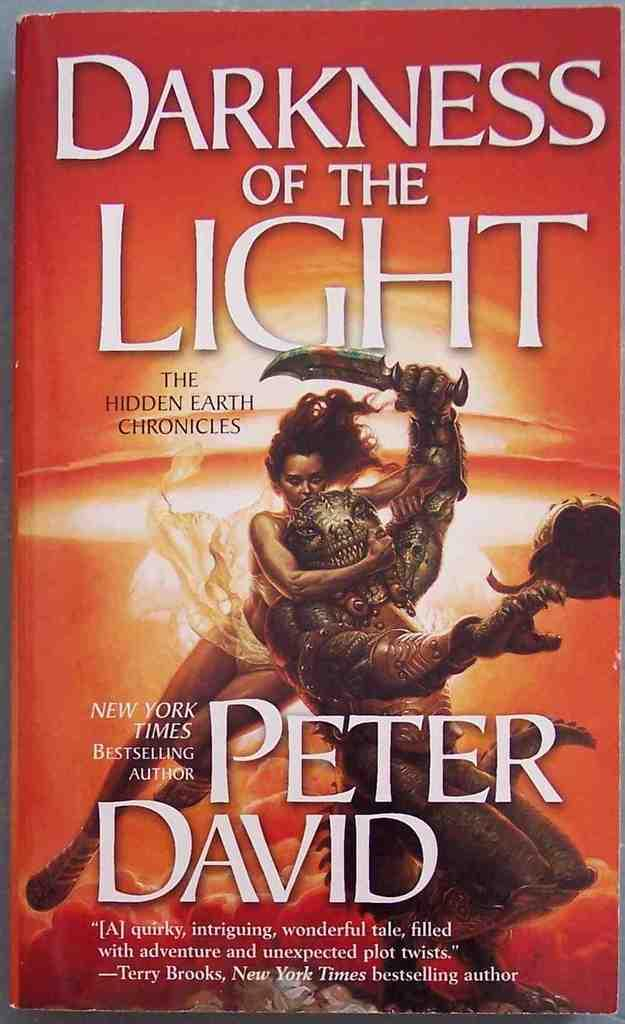<image>
Offer a succinct explanation of the picture presented. Bestselling Book from Peter David called Darkness of the Light. 